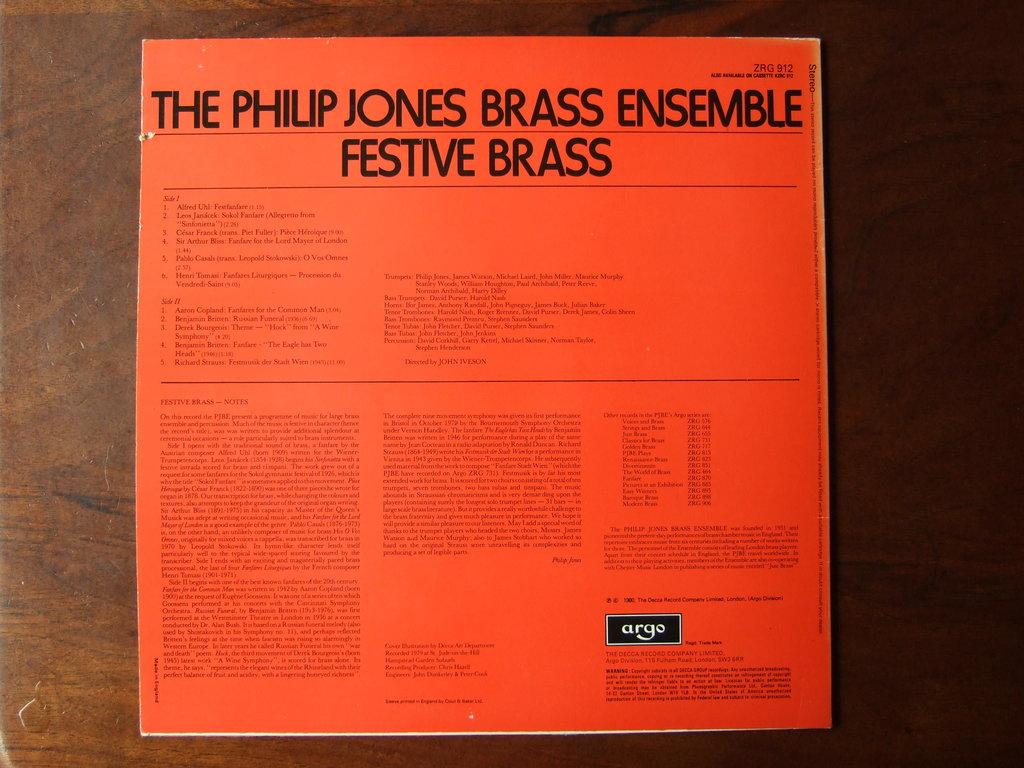Is this about a brass ensemble?
Offer a terse response. Yes. What is the name of the ensemble?
Provide a short and direct response. The philip jones brass ensemble. 